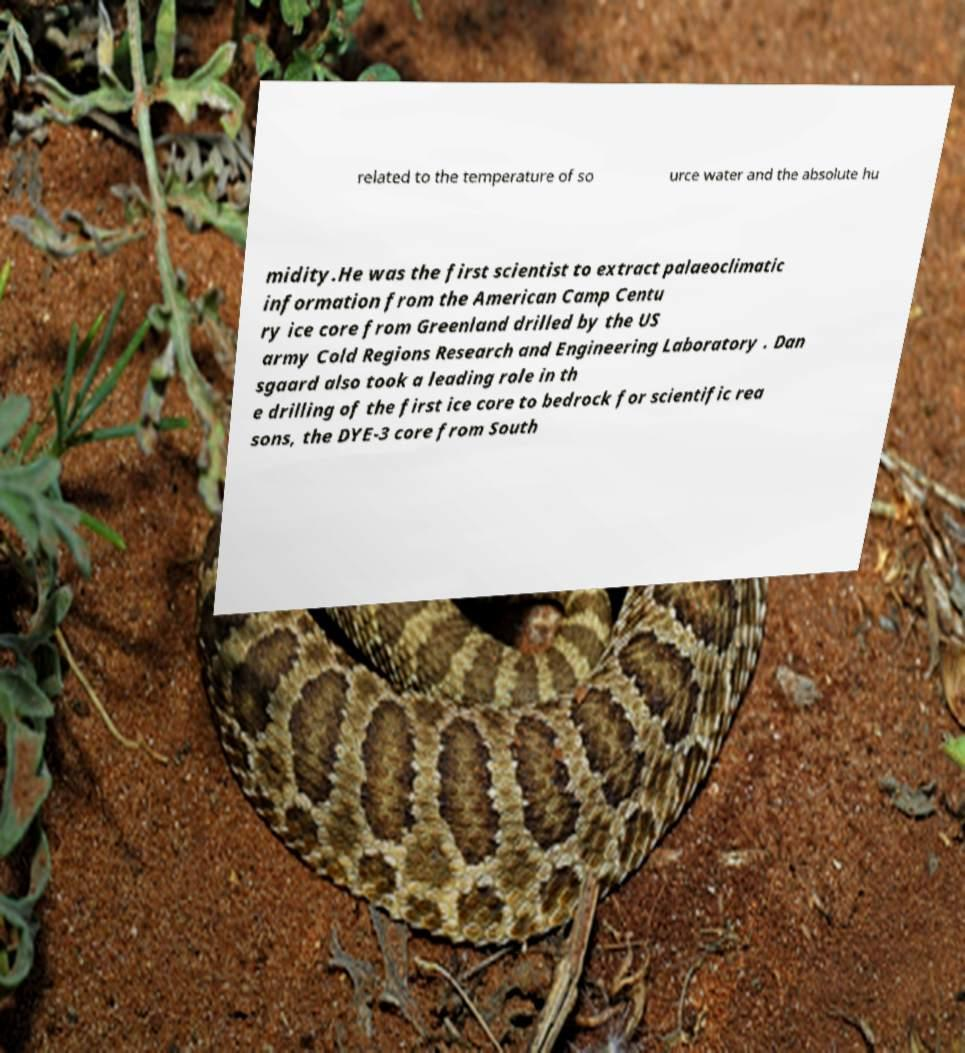What messages or text are displayed in this image? I need them in a readable, typed format. related to the temperature of so urce water and the absolute hu midity.He was the first scientist to extract palaeoclimatic information from the American Camp Centu ry ice core from Greenland drilled by the US army Cold Regions Research and Engineering Laboratory . Dan sgaard also took a leading role in th e drilling of the first ice core to bedrock for scientific rea sons, the DYE-3 core from South 